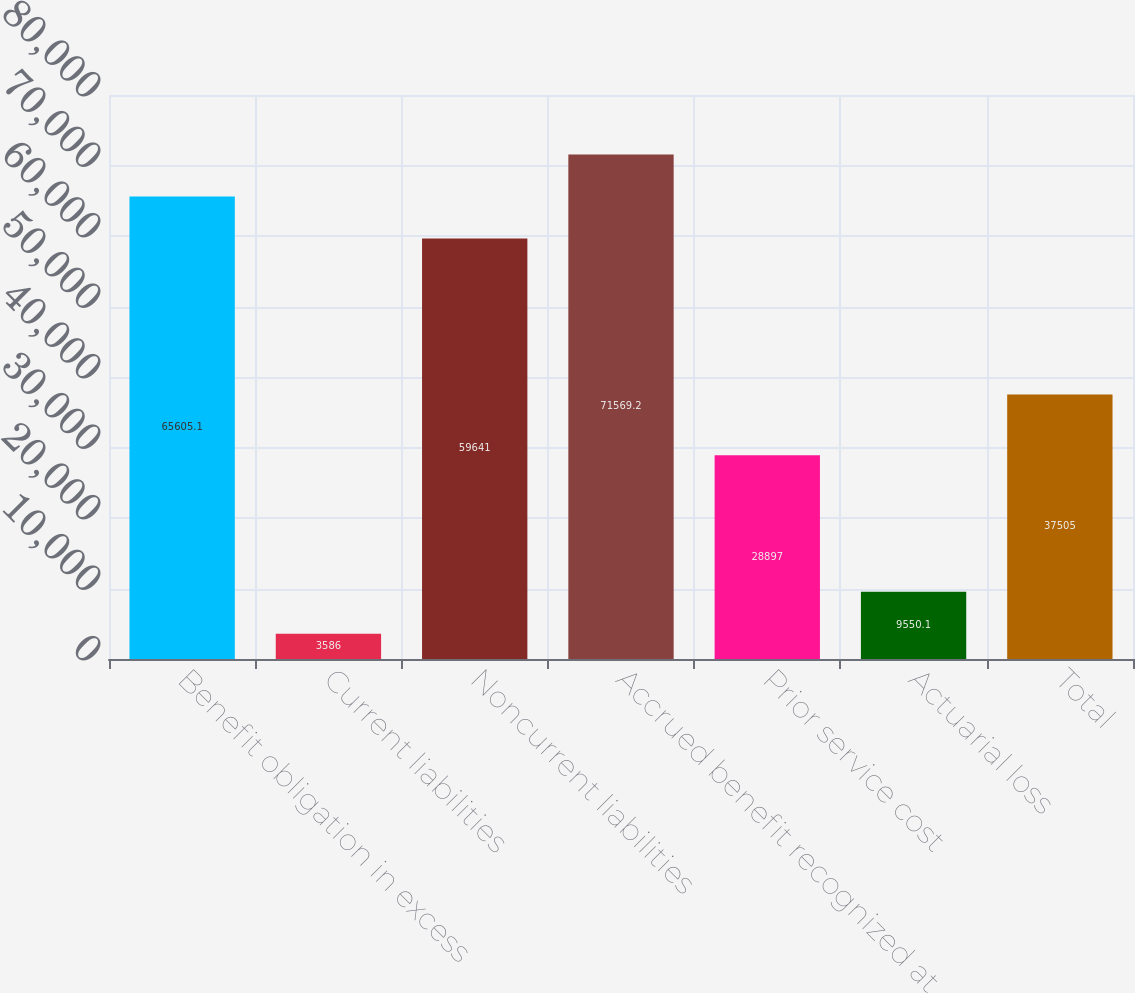Convert chart to OTSL. <chart><loc_0><loc_0><loc_500><loc_500><bar_chart><fcel>Benefit obligation in excess<fcel>Current liabilities<fcel>Noncurrent liabilities<fcel>Accrued benefit recognized at<fcel>Prior service cost<fcel>Actuarial loss<fcel>Total<nl><fcel>65605.1<fcel>3586<fcel>59641<fcel>71569.2<fcel>28897<fcel>9550.1<fcel>37505<nl></chart> 